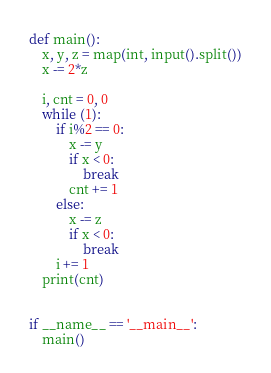<code> <loc_0><loc_0><loc_500><loc_500><_Python_>def main():
    x, y, z = map(int, input().split())
    x -= 2*z

    i, cnt = 0, 0
    while (1):
        if i%2 == 0:
            x -= y
            if x < 0:
                break
            cnt += 1
        else:
            x -= z
            if x < 0:
                break
        i += 1
    print(cnt)


if __name__ == '__main__':
    main()</code> 